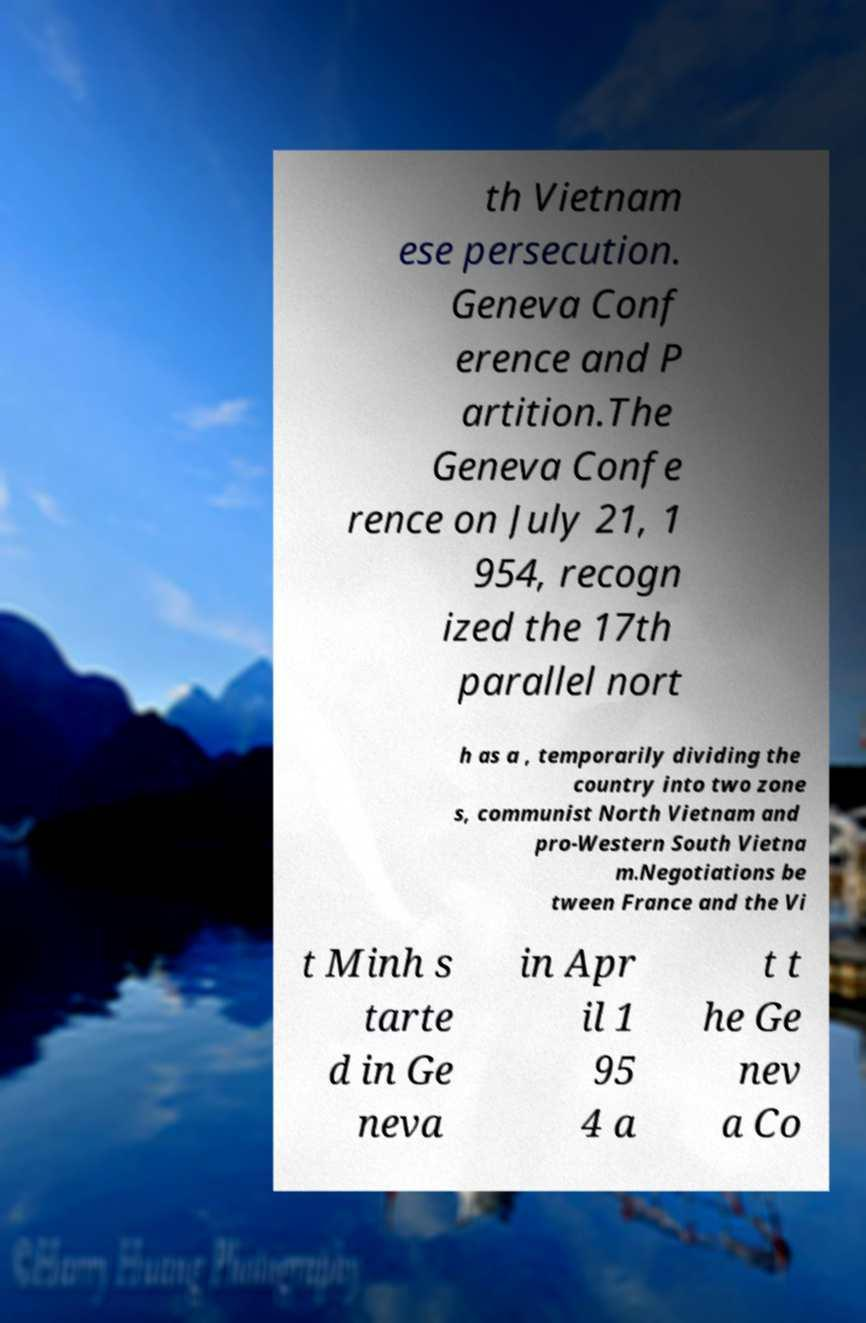Could you extract and type out the text from this image? th Vietnam ese persecution. Geneva Conf erence and P artition.The Geneva Confe rence on July 21, 1 954, recogn ized the 17th parallel nort h as a , temporarily dividing the country into two zone s, communist North Vietnam and pro-Western South Vietna m.Negotiations be tween France and the Vi t Minh s tarte d in Ge neva in Apr il 1 95 4 a t t he Ge nev a Co 